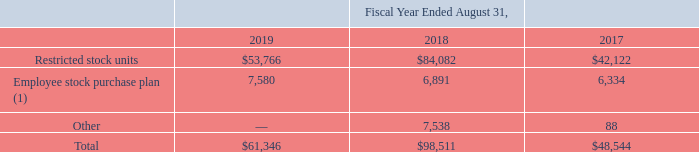11. Stockholders’ Equity
The Company recognized stock-based compensation expense within selling, general and administrative expense as follows (in thousands):
(1) For the fiscal year ended August 31, 2018, represents a one-time cash-settled stock award that vested on November 30, 2017.
What were the restricted stock units in 2019?
Answer scale should be: thousand. $53,766. What was the Employee stock purchase plan in 2018?
Answer scale should be: thousand. 6,891. What years does the table provide information for recognized stock-based compensation expense within selling, general and administrative expense for? 2019, 2018, 2017. What was the change in Other stock-based compensation expenses between 2017 and 2018?
Answer scale should be: thousand. 7,538-88
Answer: 7450. What was the change in the restricted stock units between 2018 and 2019?
Answer scale should be: thousand. $53,766-$84,082
Answer: -30316. What was the percentage change in the total stock-based compensation expense between 2018 and 2019?
Answer scale should be: percent. ($61,346-$98,511)/$98,511
Answer: -37.73. 